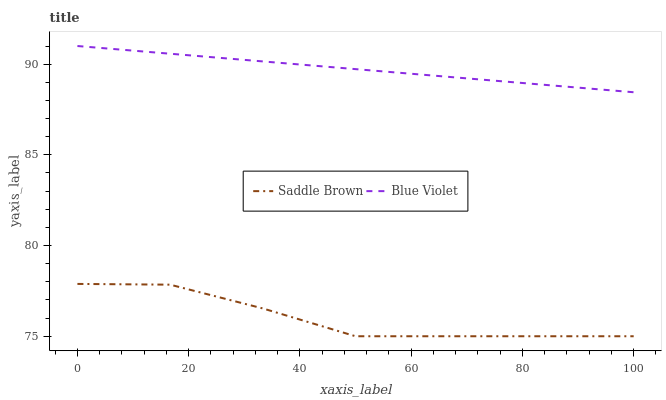Does Saddle Brown have the minimum area under the curve?
Answer yes or no. Yes. Does Blue Violet have the maximum area under the curve?
Answer yes or no. Yes. Does Blue Violet have the minimum area under the curve?
Answer yes or no. No. Is Blue Violet the smoothest?
Answer yes or no. Yes. Is Saddle Brown the roughest?
Answer yes or no. Yes. Is Blue Violet the roughest?
Answer yes or no. No. Does Saddle Brown have the lowest value?
Answer yes or no. Yes. Does Blue Violet have the lowest value?
Answer yes or no. No. Does Blue Violet have the highest value?
Answer yes or no. Yes. Is Saddle Brown less than Blue Violet?
Answer yes or no. Yes. Is Blue Violet greater than Saddle Brown?
Answer yes or no. Yes. Does Saddle Brown intersect Blue Violet?
Answer yes or no. No. 